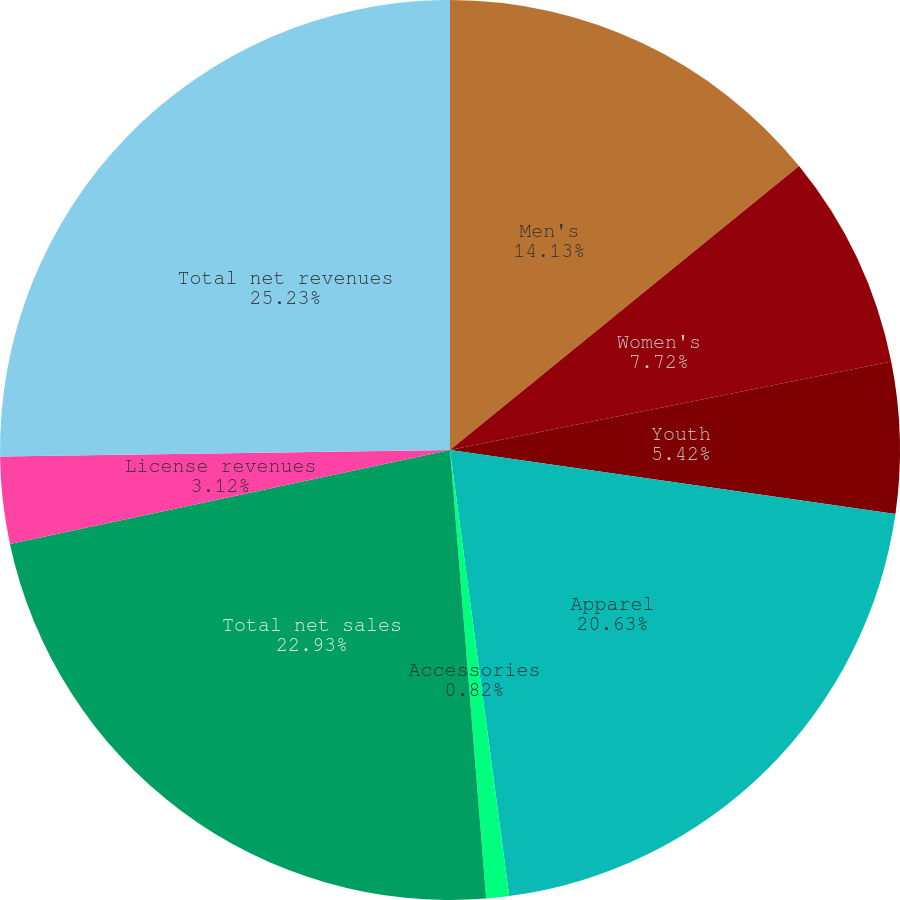Convert chart. <chart><loc_0><loc_0><loc_500><loc_500><pie_chart><fcel>Men's<fcel>Women's<fcel>Youth<fcel>Apparel<fcel>Accessories<fcel>Total net sales<fcel>License revenues<fcel>Total net revenues<nl><fcel>14.13%<fcel>7.72%<fcel>5.42%<fcel>20.63%<fcel>0.82%<fcel>22.93%<fcel>3.12%<fcel>25.23%<nl></chart> 